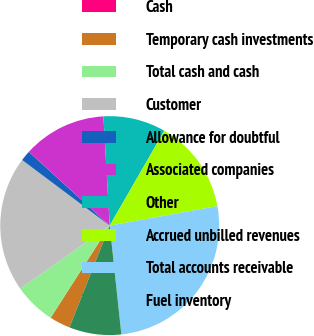Convert chart to OTSL. <chart><loc_0><loc_0><loc_500><loc_500><pie_chart><fcel>Cash<fcel>Temporary cash investments<fcel>Total cash and cash<fcel>Customer<fcel>Allowance for doubtful<fcel>Associated companies<fcel>Other<fcel>Accrued unbilled revenues<fcel>Total accounts receivable<fcel>Fuel inventory<nl><fcel>0.0%<fcel>3.08%<fcel>6.16%<fcel>20.0%<fcel>1.54%<fcel>12.31%<fcel>9.23%<fcel>13.84%<fcel>26.15%<fcel>7.69%<nl></chart> 